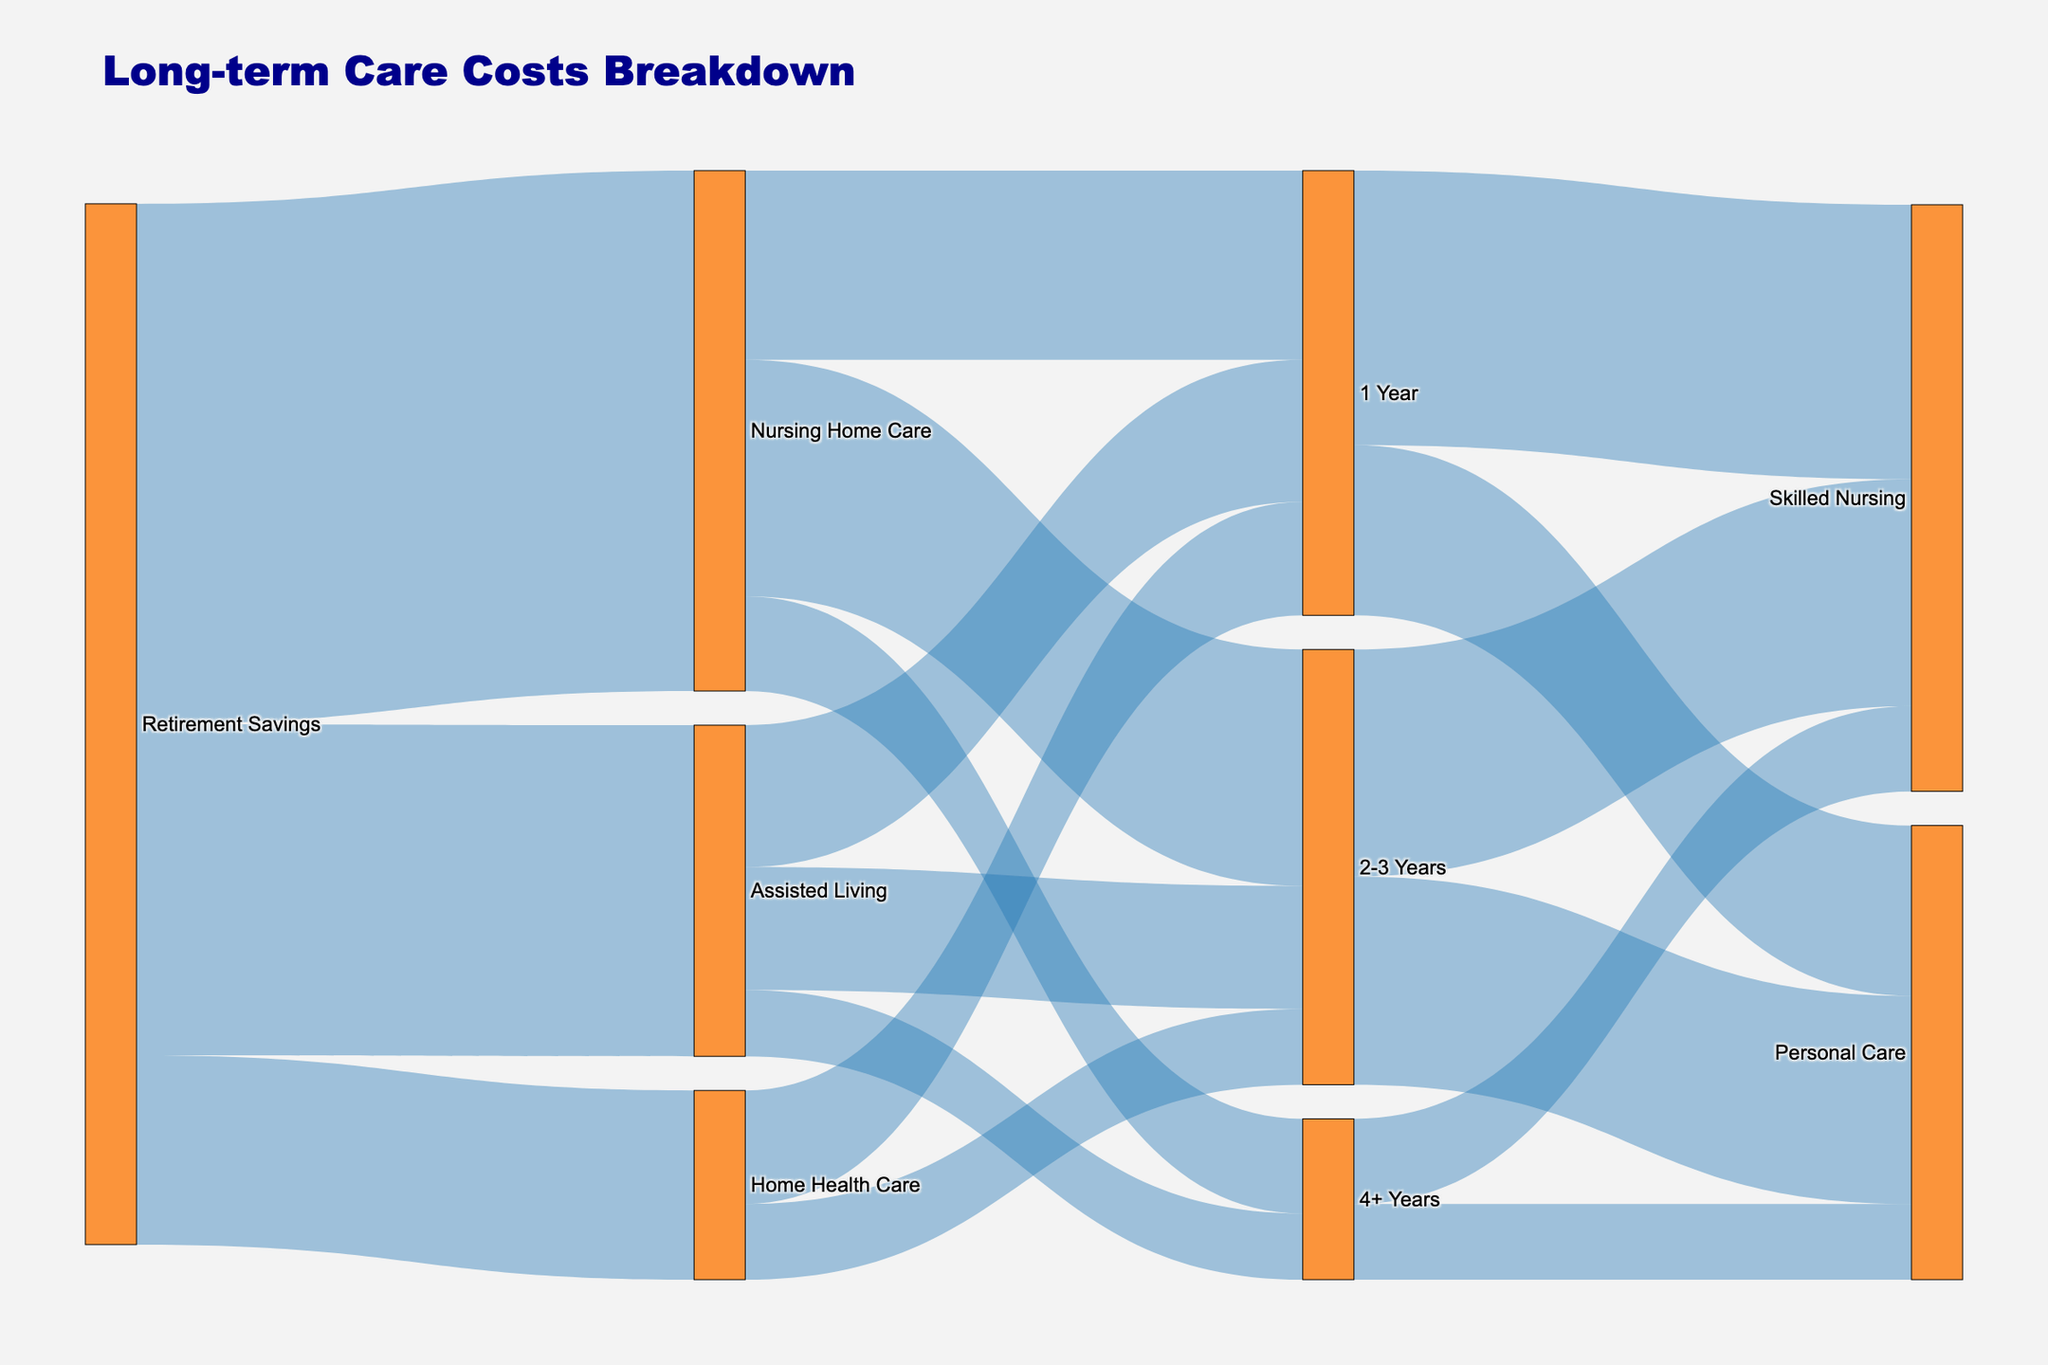What are the different service types represented in the Sankey diagram? The Sankey diagram shows three service types branching from 'Retirement Savings': 'Home Health Care', 'Assisted Living', and 'Nursing Home Care'.
Answer: Home Health Care, Assisted Living, Nursing Home Care How much of Retirement Savings is allocated to Nursing Home Care? From the diagram, the flow to 'Nursing Home Care' from 'Retirement Savings' is labeled with a value of 55000.
Answer: 55000 What duration of care has the highest allocation within Nursing Home Care? Among the durations under 'Nursing Home Care', the flow labeled with the highest value is '2-3 Years', which is 25000.
Answer: 2-3 Years What is the total amount spent on Assisted Living for all durations? For Assisted Living, the duration amounts are 15000 (1 Year), 13000 (2-3 Years), and 7000 (4+ Years). The total is 15000 + 13000 + 7000 = 35000.
Answer: 35000 Compare the costs between 1 Year Personal Care and 4+ Years Skilled Nursing. Which is higher? 1 Year Personal Care (18000) is higher than 4+ Years Skilled Nursing (9000).
Answer: 1 Year Personal Care How much is allocated from Retirement Savings to Home Health Care for the duration of 2-3 Years? The flow from 'Home Health Care' to '2-3 Years' is labeled with a value of 8000.
Answer: 8000 What is the most substantial cost component under the 2-3 Years duration? Under '2-3 Years', Skilled Nursing has a value of 24000 while Personal Care is 22000. Thus, Skilled Nursing is the most substantial component.
Answer: Skilled Nursing Which care duration within Long-term Care has the lowest total allocation? Summing up corresponding values, we get: 1 Year = 12000 (HH) + 15000 (AL) + 20000 (NHC) = 47000, 2-3 Years = 8000 (HH) + 13000 (AL) + 25000 (NHC) = 46000, and 4+ Years = 7000 (AL) + 10000 (NHC) = 17000. The lowest total allocation is for 4+ Years.
Answer: 4+ Years Considering Retirement Savings, which type of care consumes the highest proportion? The values allocated from 'Retirement Savings' are: Home Health Care (20000), Assisted Living (35000), Nursing Home Care (55000). The highest proportion is for Nursing Home Care, 55000.
Answer: Nursing Home Care 